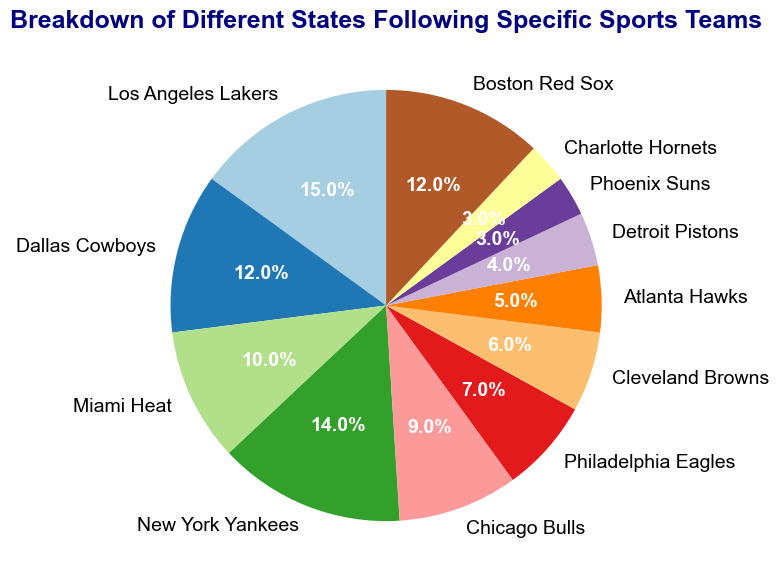Which team has the highest percentage of followers according to the pie chart? By observing the pie chart, we see that the Los Angeles Lakers have the largest slice, indicating the highest percentage.
Answer: Los Angeles Lakers Which teams have an equal percentage of followers? By looking at the pie chart, it's noticeable that Dallas Cowboys and Boston Red Sox share slices of the same size in terms of percentage.
Answer: Dallas Cowboys and Boston Red Sox What is the combined percentage of followers for the Miami Heat and Chicago Bulls? Adding the percentages for Miami Heat (10%) and Chicago Bulls (9%) as indicated in the pie chart, we get 10 + 9 = 19.
Answer: 19% Is the percentage of followers for the Atlanta Hawks greater or less than that for the Cleveland Browns? The pie chart shows that Cleveland Browns have a 6% share while Atlanta Hawks have a 5% share, which means the former is greater.
Answer: Less than What is the difference in percentage between the New York Yankees and the Detroit Pistons? Subtract the percentage of the Detroit Pistons (4%) from the New York Yankees (14%), which is 14 - 4 = 10.
Answer: 10% Which team represents the smallest percentage of followers? By observing the smallest slice in the pie chart, it's evident that both Phoenix Suns and Charlotte Hornets have equal and the lowest percentages.
Answer: Phoenix Suns and Charlotte Hornets What is the total percentage of followers for Los Angeles Lakers, New York Yankees, and Dallas Cowboys combined? Summing the percentages for Los Angeles Lakers (15%), New York Yankees (14%), and Dallas Cowboys (12%) as shown in the pie chart, we get 15 + 14 + 12 = 41.
Answer: 41% Are there more followers for Texas-based teams or Florida-based teams? Texas-based teams (Dallas Cowboys) have 12%, and Florida-based teams (Miami Heat) have 10%, indicating that Texas-based teams have more followers.
Answer: Texas-based teams 